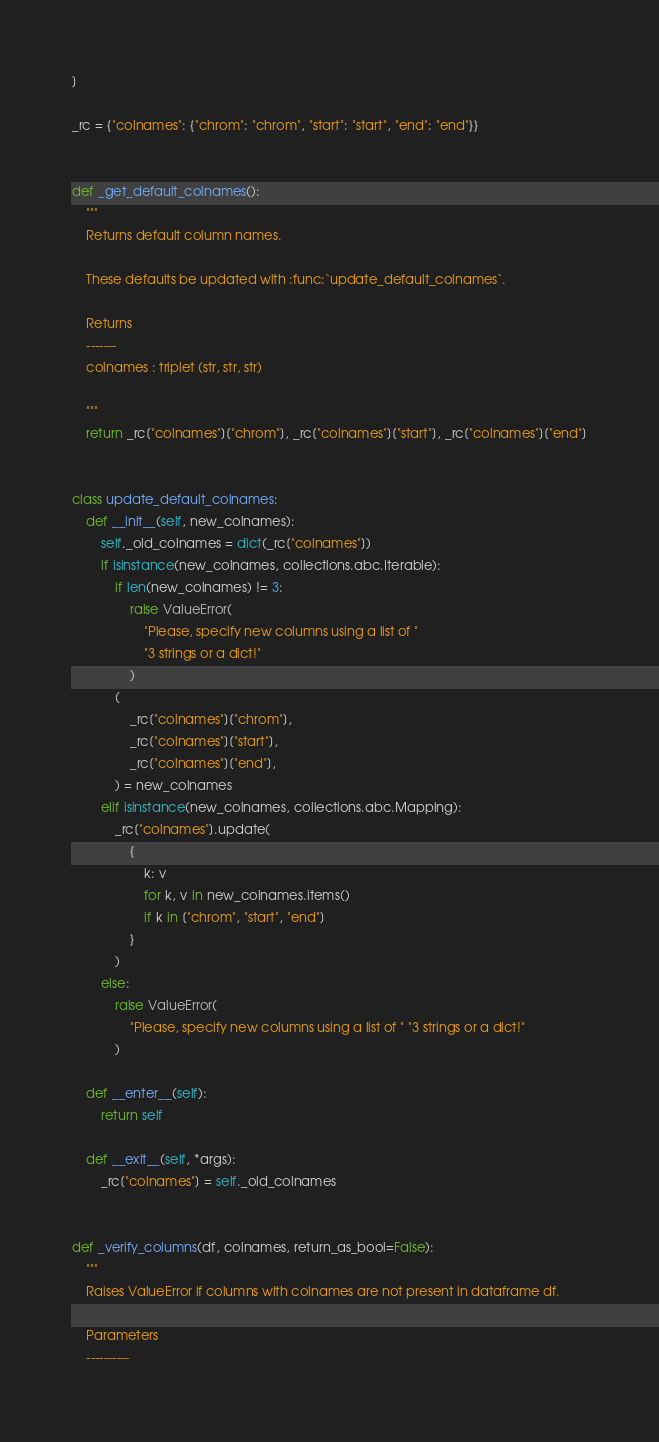Convert code to text. <code><loc_0><loc_0><loc_500><loc_500><_Python_>]

_rc = {"colnames": {"chrom": "chrom", "start": "start", "end": "end"}}


def _get_default_colnames():
    """
    Returns default column names.

    These defaults be updated with :func:`update_default_colnames`.

    Returns
    -------
    colnames : triplet (str, str, str)

    """
    return _rc["colnames"]["chrom"], _rc["colnames"]["start"], _rc["colnames"]["end"]


class update_default_colnames:
    def __init__(self, new_colnames):
        self._old_colnames = dict(_rc["colnames"])
        if isinstance(new_colnames, collections.abc.Iterable):
            if len(new_colnames) != 3:
                raise ValueError(
                    "Please, specify new columns using a list of "
                    "3 strings or a dict!"
                )
            (
                _rc["colnames"]["chrom"],
                _rc["colnames"]["start"],
                _rc["colnames"]["end"],
            ) = new_colnames
        elif isinstance(new_colnames, collections.abc.Mapping):
            _rc["colnames"].update(
                {
                    k: v
                    for k, v in new_colnames.items()
                    if k in ["chrom", "start", "end"]
                }
            )
        else:
            raise ValueError(
                "Please, specify new columns using a list of " "3 strings or a dict!"
            )

    def __enter__(self):
        return self

    def __exit__(self, *args):
        _rc["colnames"] = self._old_colnames


def _verify_columns(df, colnames, return_as_bool=False):
    """
    Raises ValueError if columns with colnames are not present in dataframe df.

    Parameters
    ----------</code> 